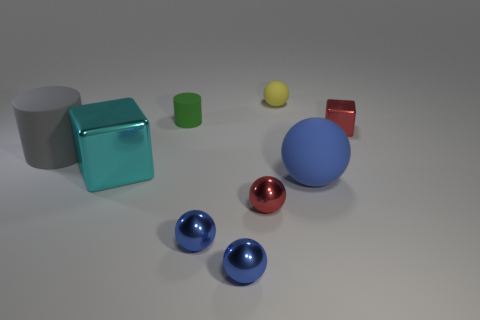If I were to arrange these objects by weight, from lightest to heaviest, how should they be ordered? While I cannot provide the specific weights without additional data, a plausible order from lightest to heaviest based on the materials visible could be: the small rubber cylinder and yellow ball, the red cube, blue balls, the large cyan block, and finally the large gray metal cube. 